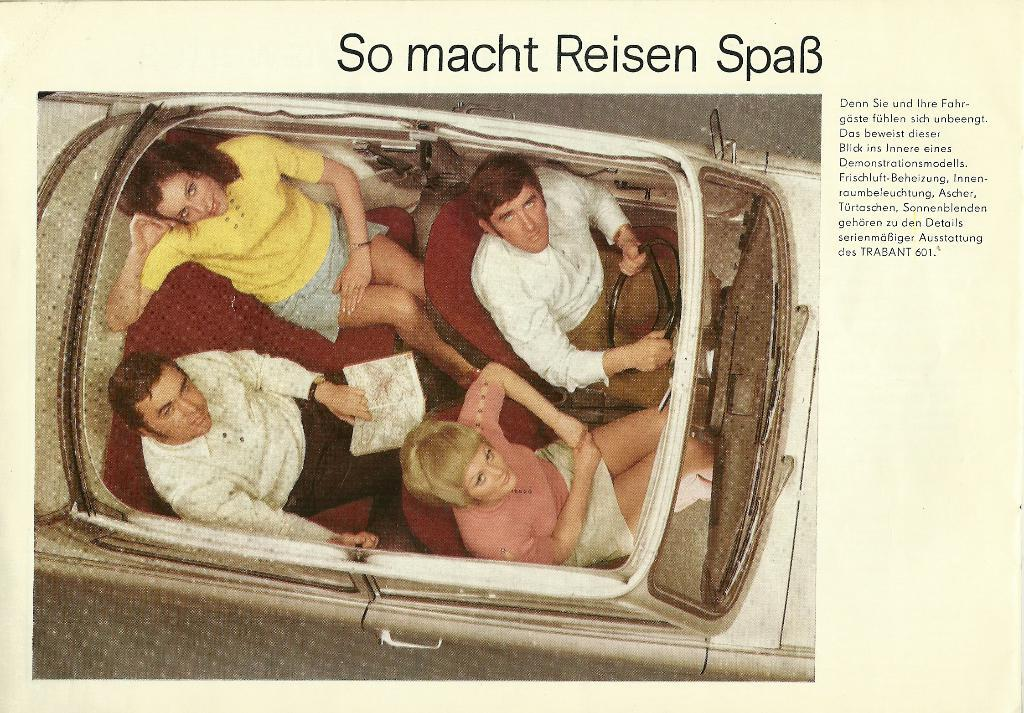What is featured on the poster in the image? There is a poster in the image, and it has an image of a car. Who or what is depicted inside the car? There are two women and two men sitting in the car. What else can be seen on the poster besides the car image? There is text on the poster. What type of tent can be seen in the aftermath of the car accident in the image? There is no tent or car accident present in the image. How is the transport system affected by the incident in the image? There is no incident or transport system mentioned in the image. 